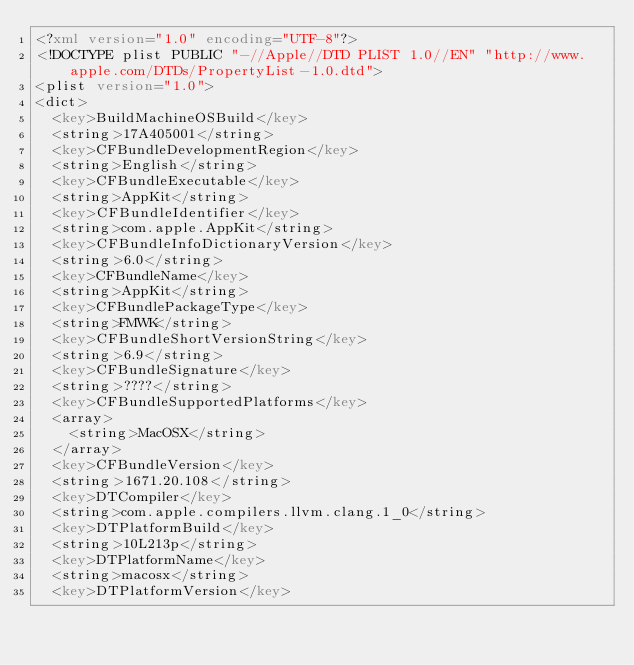Convert code to text. <code><loc_0><loc_0><loc_500><loc_500><_XML_><?xml version="1.0" encoding="UTF-8"?>
<!DOCTYPE plist PUBLIC "-//Apple//DTD PLIST 1.0//EN" "http://www.apple.com/DTDs/PropertyList-1.0.dtd">
<plist version="1.0">
<dict>
	<key>BuildMachineOSBuild</key>
	<string>17A405001</string>
	<key>CFBundleDevelopmentRegion</key>
	<string>English</string>
	<key>CFBundleExecutable</key>
	<string>AppKit</string>
	<key>CFBundleIdentifier</key>
	<string>com.apple.AppKit</string>
	<key>CFBundleInfoDictionaryVersion</key>
	<string>6.0</string>
	<key>CFBundleName</key>
	<string>AppKit</string>
	<key>CFBundlePackageType</key>
	<string>FMWK</string>
	<key>CFBundleShortVersionString</key>
	<string>6.9</string>
	<key>CFBundleSignature</key>
	<string>????</string>
	<key>CFBundleSupportedPlatforms</key>
	<array>
		<string>MacOSX</string>
	</array>
	<key>CFBundleVersion</key>
	<string>1671.20.108</string>
	<key>DTCompiler</key>
	<string>com.apple.compilers.llvm.clang.1_0</string>
	<key>DTPlatformBuild</key>
	<string>10L213p</string>
	<key>DTPlatformName</key>
	<string>macosx</string>
	<key>DTPlatformVersion</key></code> 